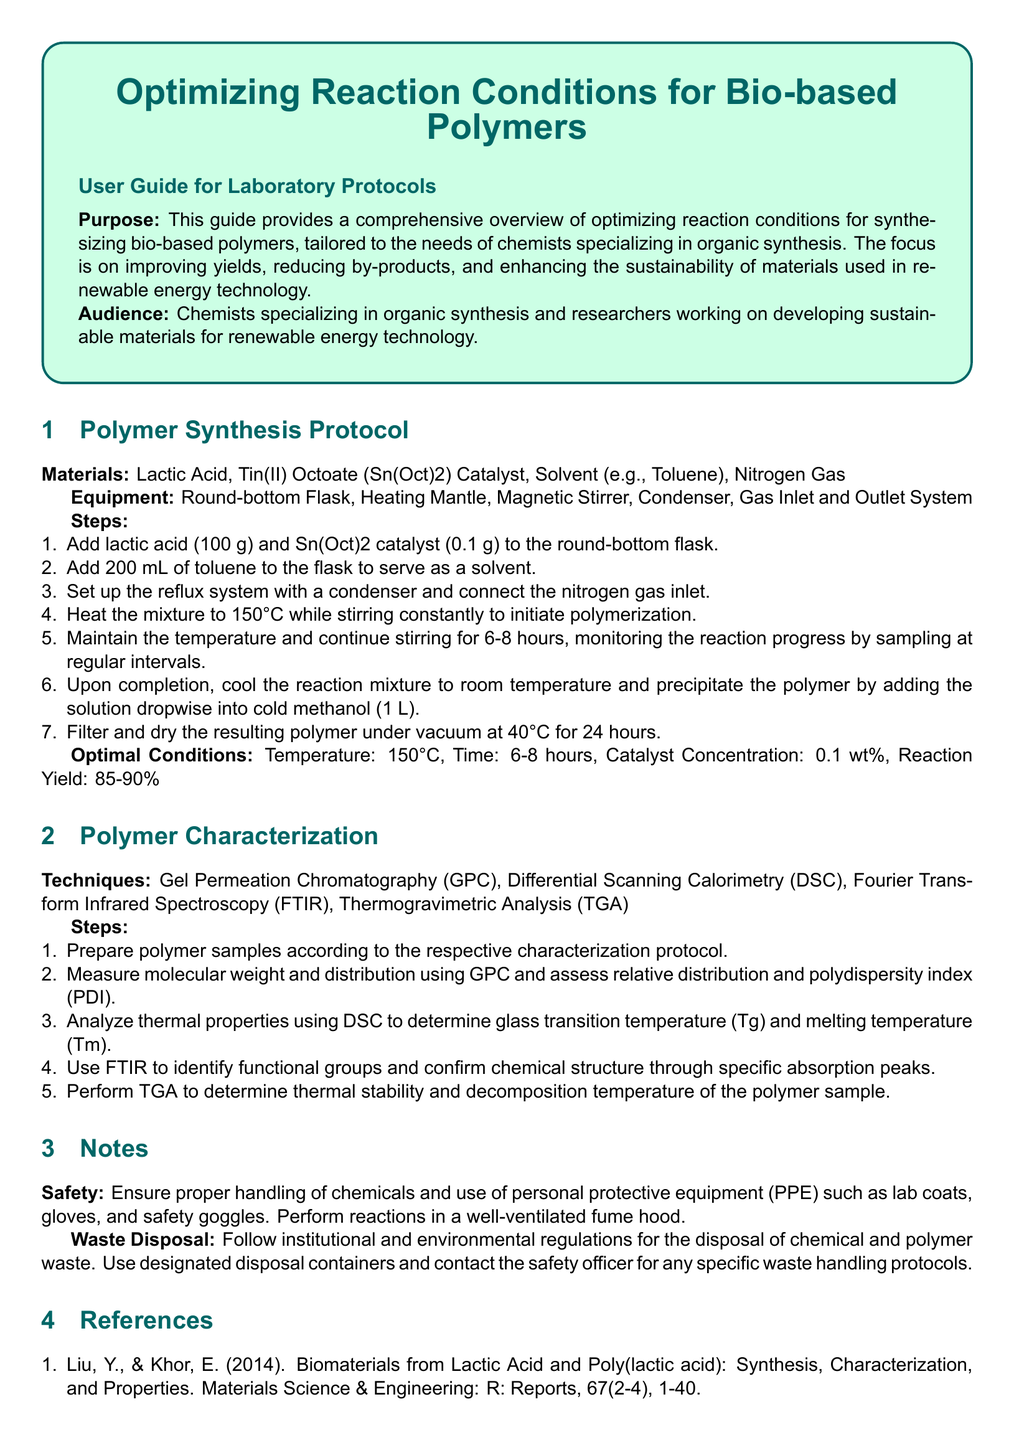What is the main purpose of this user guide? The main purpose is to provide a comprehensive overview of optimizing reaction conditions for synthesizing bio-based polymers.
Answer: optimizing reaction conditions for synthesizing bio-based polymers What is the catalyst used in the polymer synthesis protocol? The catalyst mentioned in the protocol is Tin(II) Octoate (Sn(Oct)2).
Answer: Tin(II) Octoate (Sn(Oct)2) What is the optimal reaction temperature for the synthesis? The optimal reaction temperature specified in the document is 150°C.
Answer: 150°C What techniques are used for polymer characterization? The techniques listed for characterization are Gel Permeation Chromatography (GPC), Differential Scanning Calorimetry (DSC), Fourier Transform Infrared Spectroscopy (FTIR), and Thermogravimetric Analysis (TGA).
Answer: GPC, DSC, FTIR, TGA What is the expected reaction yield range? The expected reaction yield range provided is 85-90%.
Answer: 85-90% Why is safety emphasized in this document? Safety is emphasized to ensure proper handling of chemicals and the use of personal protective equipment (PPE).
Answer: proper handling of chemicals and use of PPE What should be done with chemical and polymer waste? The document states that waste should be disposed of according to institutional and environmental regulations.
Answer: according to institutional and environmental regulations Who is the intended audience for this user guide? The intended audience is chemists specializing in organic synthesis and researchers in sustainable materials for renewable energy technology.
Answer: chemists and researchers in sustainable materials What is the volume of solvent recommended in the protocol? The volume of solvent recommended in the protocol is 200 mL.
Answer: 200 mL 